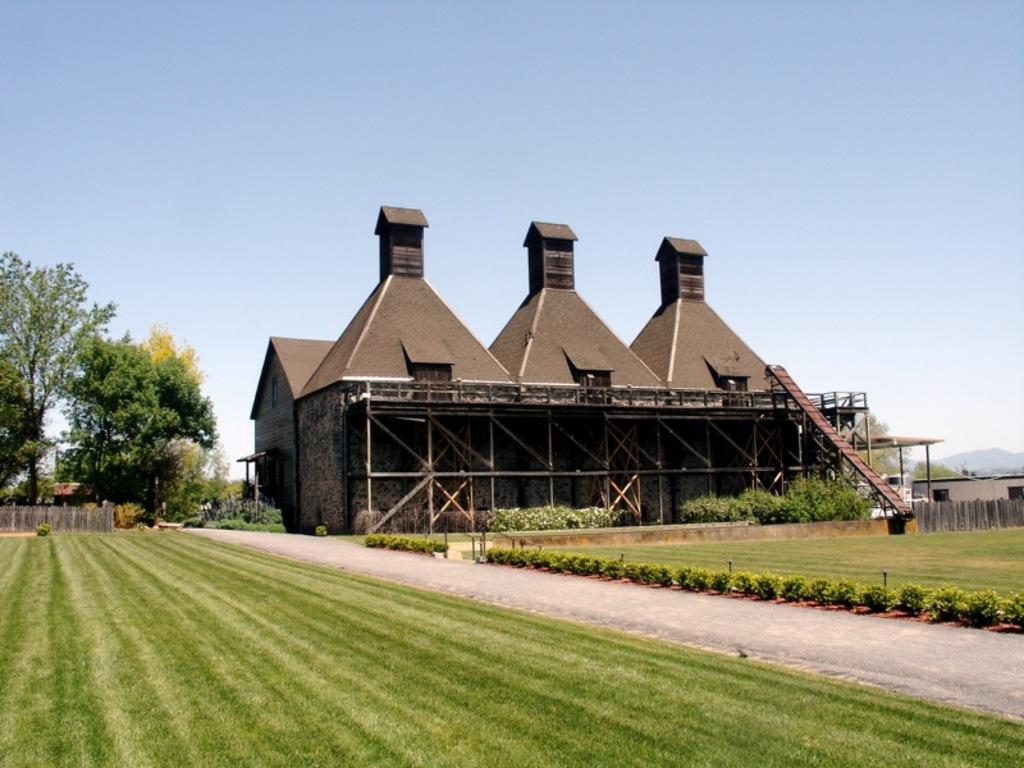What type of terrain is visible in the image? There is an open grass ground in the image. Is there any indication of a path or walkway in the image? Yes, there is a path in the image. What other natural elements can be seen in the image? There are plants and trees in the image. Are there any man-made structures visible in the image? Yes, there are buildings in the image. What can be seen in the background of the image? The sky is visible in the background of the image. How does the country feel about the mom in the image? There is no information about a country, mom, or any emotions in the image. 